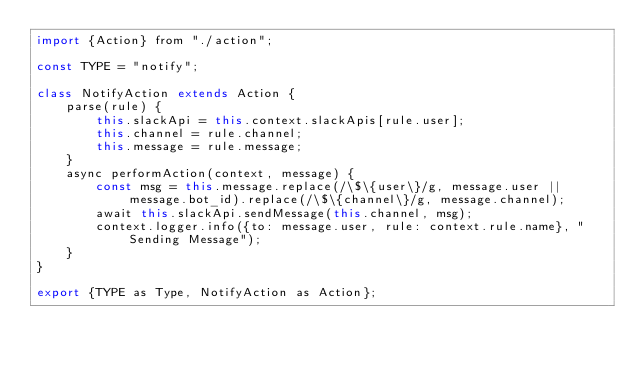<code> <loc_0><loc_0><loc_500><loc_500><_JavaScript_>import {Action} from "./action";

const TYPE = "notify";

class NotifyAction extends Action {
    parse(rule) {
        this.slackApi = this.context.slackApis[rule.user];
        this.channel = rule.channel;
        this.message = rule.message;
    }
    async performAction(context, message) {
        const msg = this.message.replace(/\$\{user\}/g, message.user || message.bot_id).replace(/\$\{channel\}/g, message.channel);
        await this.slackApi.sendMessage(this.channel, msg);
        context.logger.info({to: message.user, rule: context.rule.name}, "Sending Message");
    }
}

export {TYPE as Type, NotifyAction as Action};
</code> 